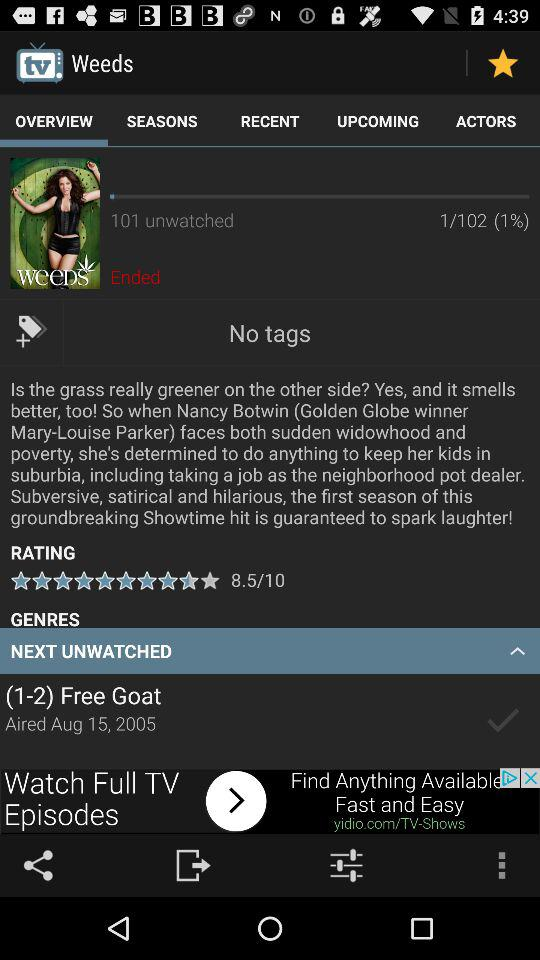What is the percentage of the unwatched?
When the provided information is insufficient, respond with <no answer>. <no answer> 